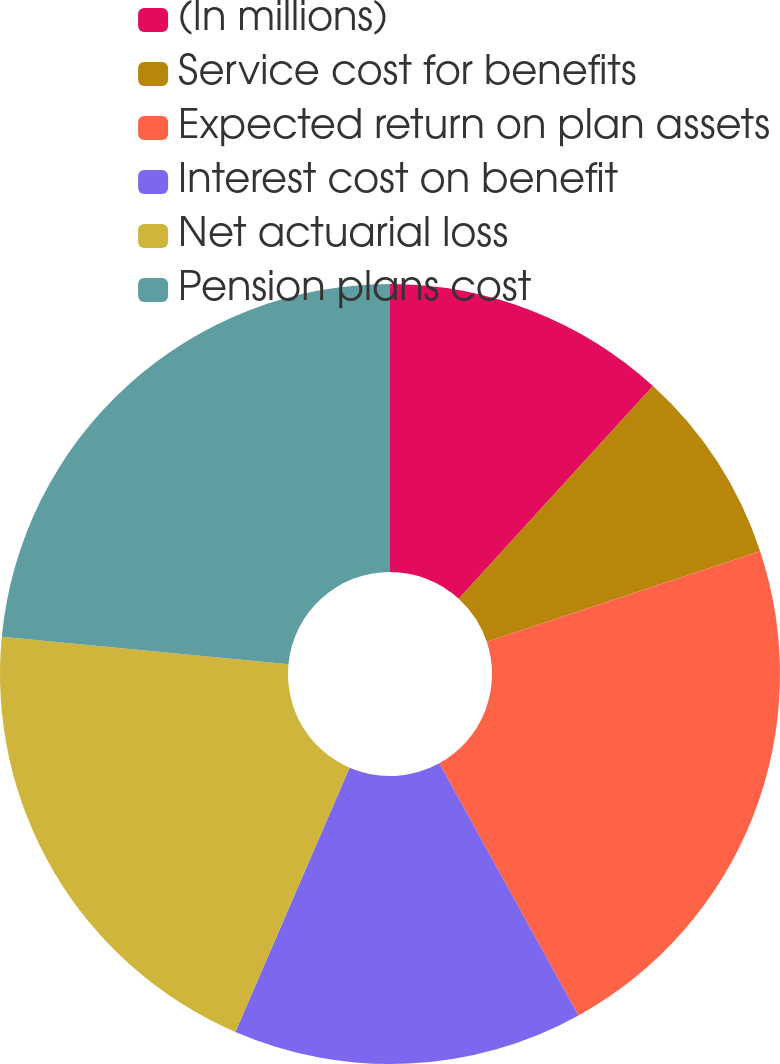Convert chart. <chart><loc_0><loc_0><loc_500><loc_500><pie_chart><fcel>(In millions)<fcel>Service cost for benefits<fcel>Expected return on plan assets<fcel>Interest cost on benefit<fcel>Net actuarial loss<fcel>Pension plans cost<nl><fcel>11.78%<fcel>8.12%<fcel>22.07%<fcel>14.52%<fcel>20.03%<fcel>23.48%<nl></chart> 